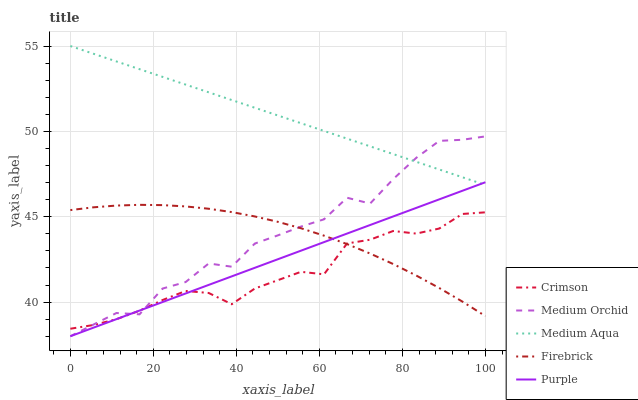Does Crimson have the minimum area under the curve?
Answer yes or no. Yes. Does Medium Aqua have the maximum area under the curve?
Answer yes or no. Yes. Does Purple have the minimum area under the curve?
Answer yes or no. No. Does Purple have the maximum area under the curve?
Answer yes or no. No. Is Medium Aqua the smoothest?
Answer yes or no. Yes. Is Medium Orchid the roughest?
Answer yes or no. Yes. Is Purple the smoothest?
Answer yes or no. No. Is Purple the roughest?
Answer yes or no. No. Does Purple have the lowest value?
Answer yes or no. Yes. Does Firebrick have the lowest value?
Answer yes or no. No. Does Medium Aqua have the highest value?
Answer yes or no. Yes. Does Purple have the highest value?
Answer yes or no. No. Is Firebrick less than Medium Aqua?
Answer yes or no. Yes. Is Medium Aqua greater than Firebrick?
Answer yes or no. Yes. Does Firebrick intersect Purple?
Answer yes or no. Yes. Is Firebrick less than Purple?
Answer yes or no. No. Is Firebrick greater than Purple?
Answer yes or no. No. Does Firebrick intersect Medium Aqua?
Answer yes or no. No. 